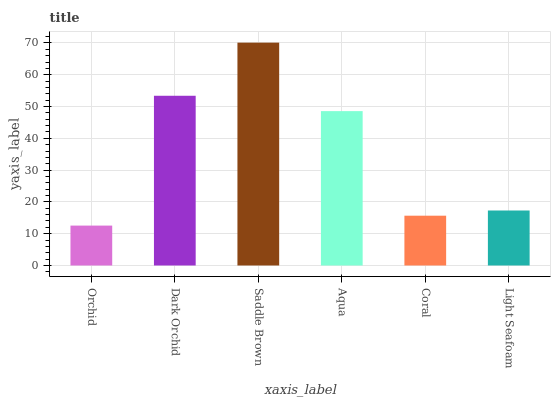Is Orchid the minimum?
Answer yes or no. Yes. Is Saddle Brown the maximum?
Answer yes or no. Yes. Is Dark Orchid the minimum?
Answer yes or no. No. Is Dark Orchid the maximum?
Answer yes or no. No. Is Dark Orchid greater than Orchid?
Answer yes or no. Yes. Is Orchid less than Dark Orchid?
Answer yes or no. Yes. Is Orchid greater than Dark Orchid?
Answer yes or no. No. Is Dark Orchid less than Orchid?
Answer yes or no. No. Is Aqua the high median?
Answer yes or no. Yes. Is Light Seafoam the low median?
Answer yes or no. Yes. Is Orchid the high median?
Answer yes or no. No. Is Saddle Brown the low median?
Answer yes or no. No. 